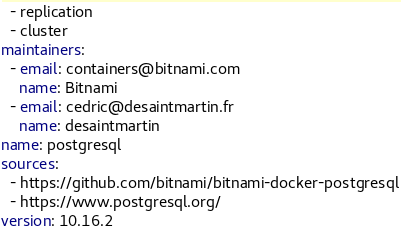Convert code to text. <code><loc_0><loc_0><loc_500><loc_500><_YAML_>  - replication
  - cluster
maintainers:
  - email: containers@bitnami.com
    name: Bitnami
  - email: cedric@desaintmartin.fr
    name: desaintmartin
name: postgresql
sources:
  - https://github.com/bitnami/bitnami-docker-postgresql
  - https://www.postgresql.org/
version: 10.16.2
</code> 